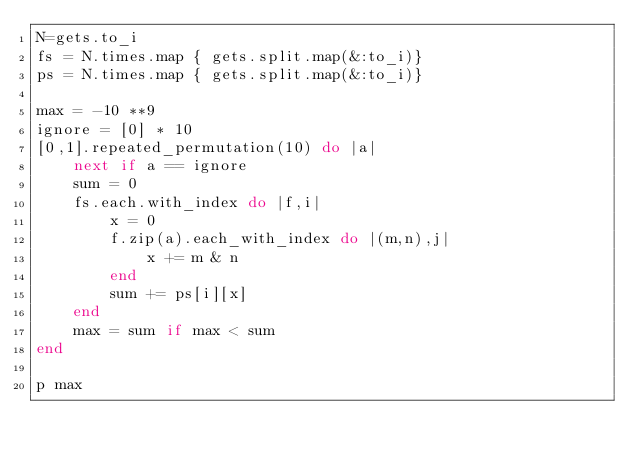<code> <loc_0><loc_0><loc_500><loc_500><_Ruby_>N=gets.to_i
fs = N.times.map { gets.split.map(&:to_i)}
ps = N.times.map { gets.split.map(&:to_i)}

max = -10 **9
ignore = [0] * 10
[0,1].repeated_permutation(10) do |a|
    next if a == ignore
    sum = 0
    fs.each.with_index do |f,i|
        x = 0
        f.zip(a).each_with_index do |(m,n),j|
            x += m & n
        end
        sum += ps[i][x]
    end
    max = sum if max < sum
end

p max</code> 